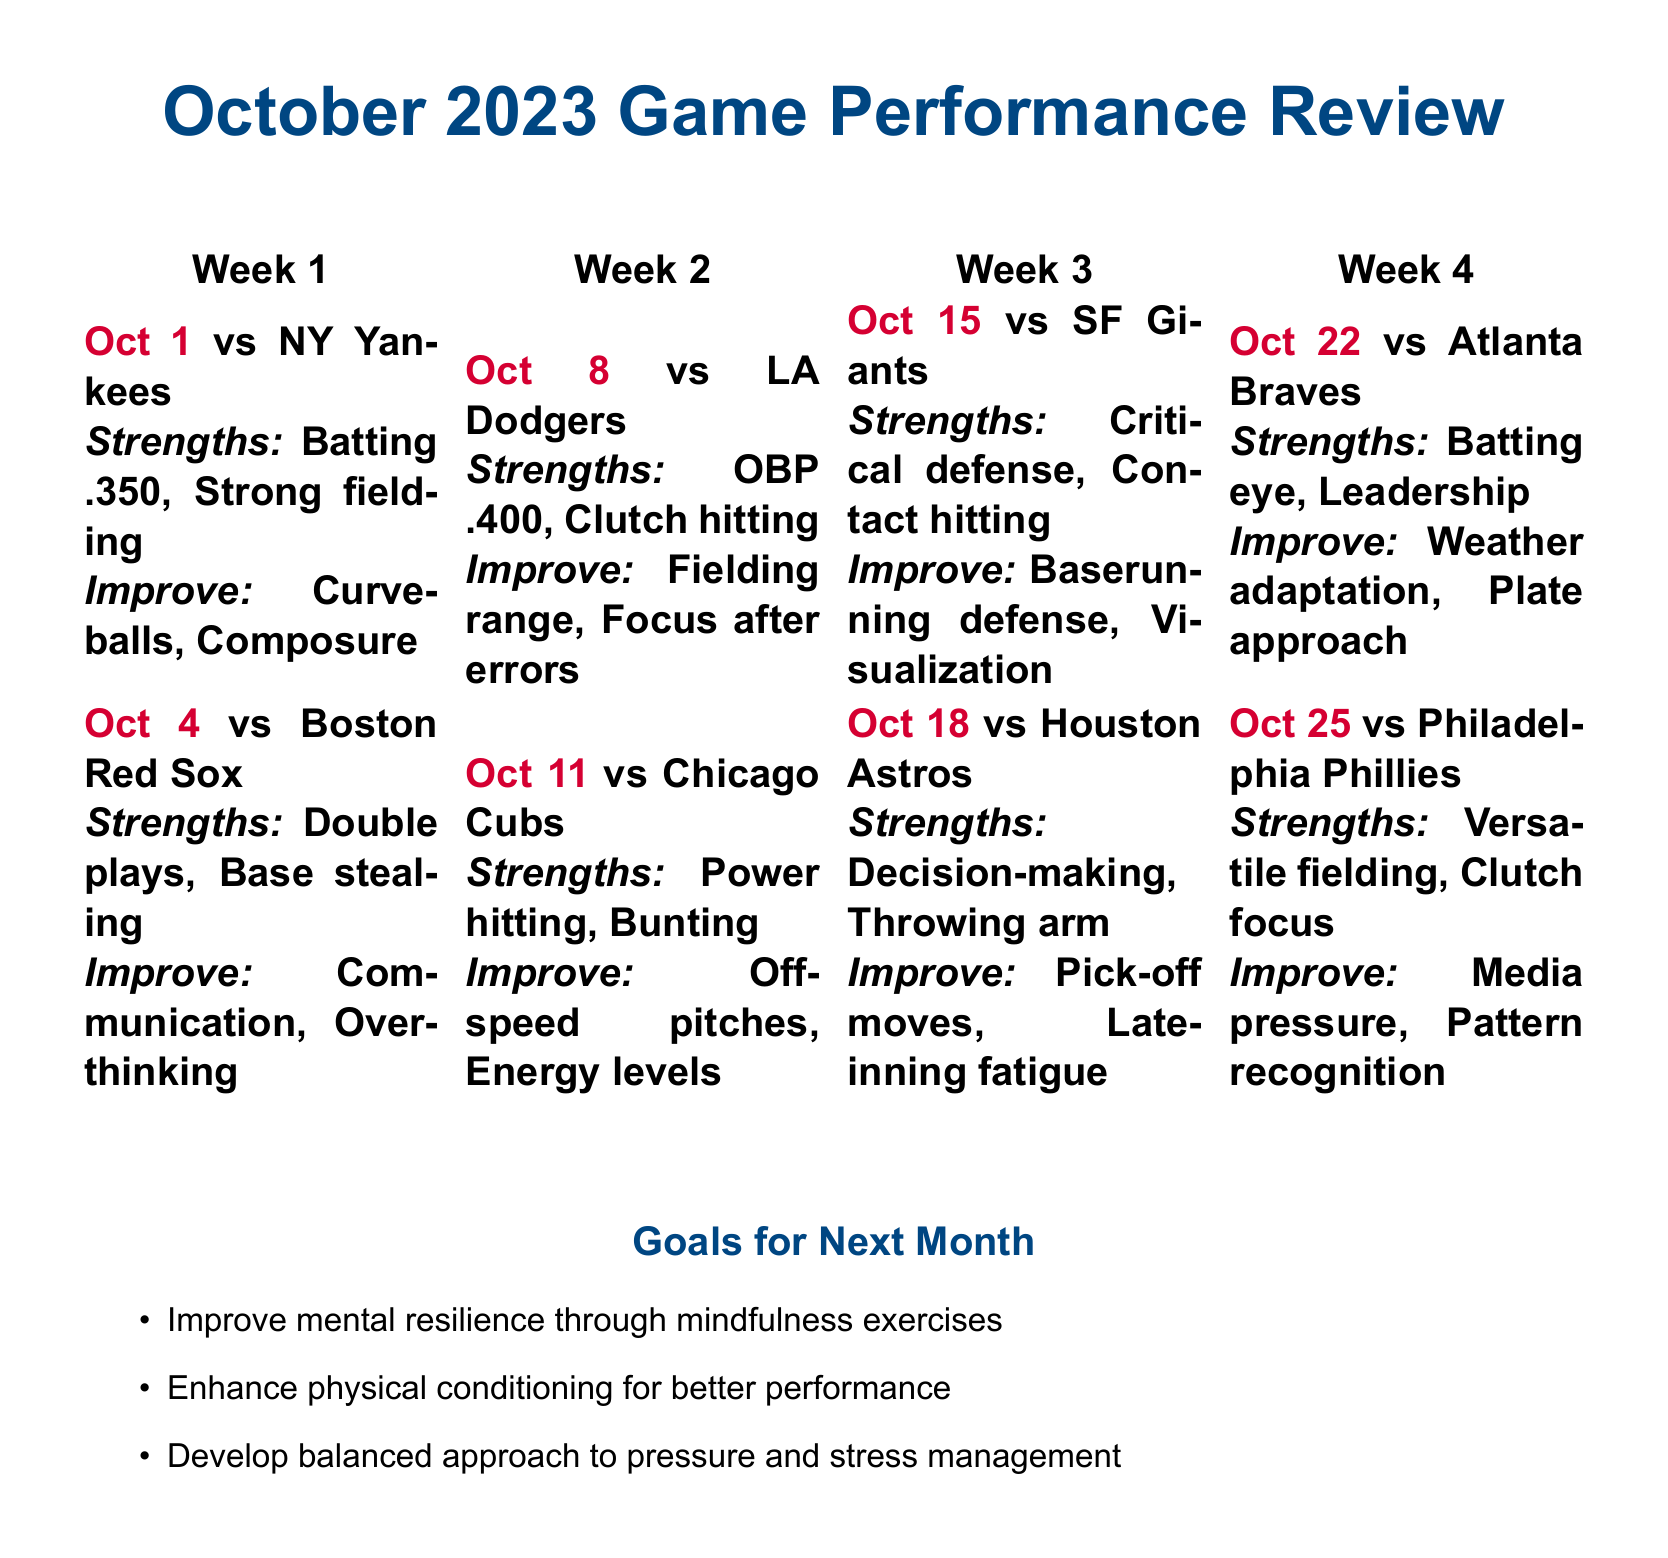What is the date of the first game reviewed? The first game reviewed took place on October 1.
Answer: October 1 What team did you play against on October 4? The game on October 4 was against the Boston Red Sox.
Answer: Boston Red Sox What was one of the strengths highlighted for the game against the SF Giants? Critical defense was highlighted as a strength in the game against the SF Giants.
Answer: Critical defense How many games are reviewed in total for October? There are a total of 8 games reviewed in the document.
Answer: 8 What specific area for improvement is mentioned after the game against the LA Dodgers? Fielding range is mentioned as an area for improvement after the game against the LA Dodgers.
Answer: Fielding range What is one of the goals for the next month? One of the goals for next month is to improve mental resilience through mindfulness exercises.
Answer: Improve mental resilience through mindfulness exercises Which game had a focus on media pressure as an area for improvement? The game against the Philadelphia Phillies emphasized media pressure as an area for improvement.
Answer: Philadelphia Phillies How is the performance in batting described for the game on October 8? The batting performance for the game on October 8 is described as an On-Base Percentage of .400.
Answer: OBP .400 